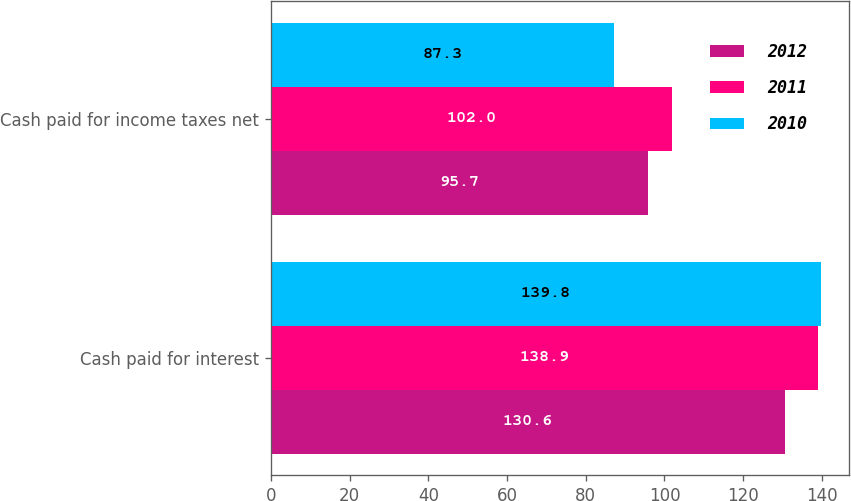<chart> <loc_0><loc_0><loc_500><loc_500><stacked_bar_chart><ecel><fcel>Cash paid for interest<fcel>Cash paid for income taxes net<nl><fcel>2012<fcel>130.6<fcel>95.7<nl><fcel>2011<fcel>138.9<fcel>102<nl><fcel>2010<fcel>139.8<fcel>87.3<nl></chart> 